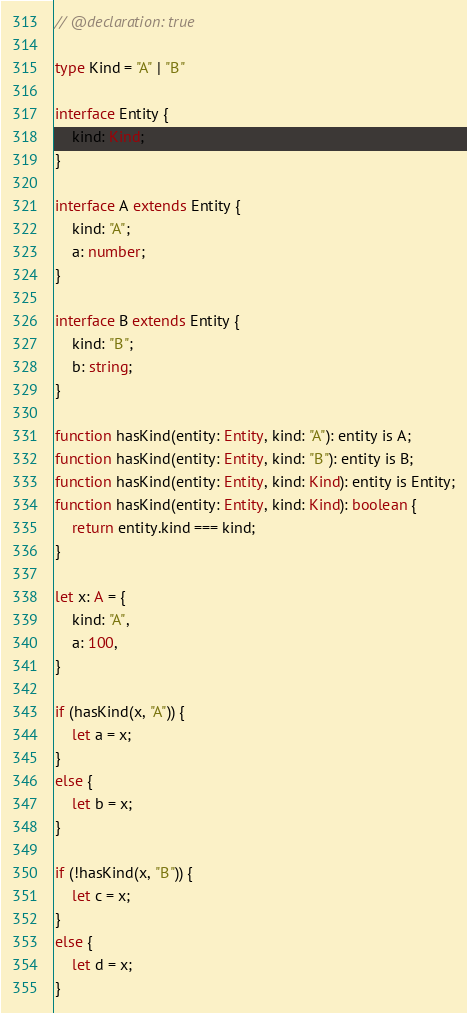Convert code to text. <code><loc_0><loc_0><loc_500><loc_500><_TypeScript_>// @declaration: true

type Kind = "A" | "B"

interface Entity {
    kind: Kind;
}

interface A extends Entity {
    kind: "A";
    a: number;
}

interface B extends Entity {
    kind: "B";
    b: string;
}

function hasKind(entity: Entity, kind: "A"): entity is A;
function hasKind(entity: Entity, kind: "B"): entity is B;
function hasKind(entity: Entity, kind: Kind): entity is Entity;
function hasKind(entity: Entity, kind: Kind): boolean {
    return entity.kind === kind;
}

let x: A = {
    kind: "A",
    a: 100,
}

if (hasKind(x, "A")) {
    let a = x;
}
else {
    let b = x;
}

if (!hasKind(x, "B")) {
    let c = x;
}
else {
    let d = x;
}</code> 